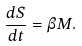Convert formula to latex. <formula><loc_0><loc_0><loc_500><loc_500>\frac { d S } { d t } = \beta M .</formula> 